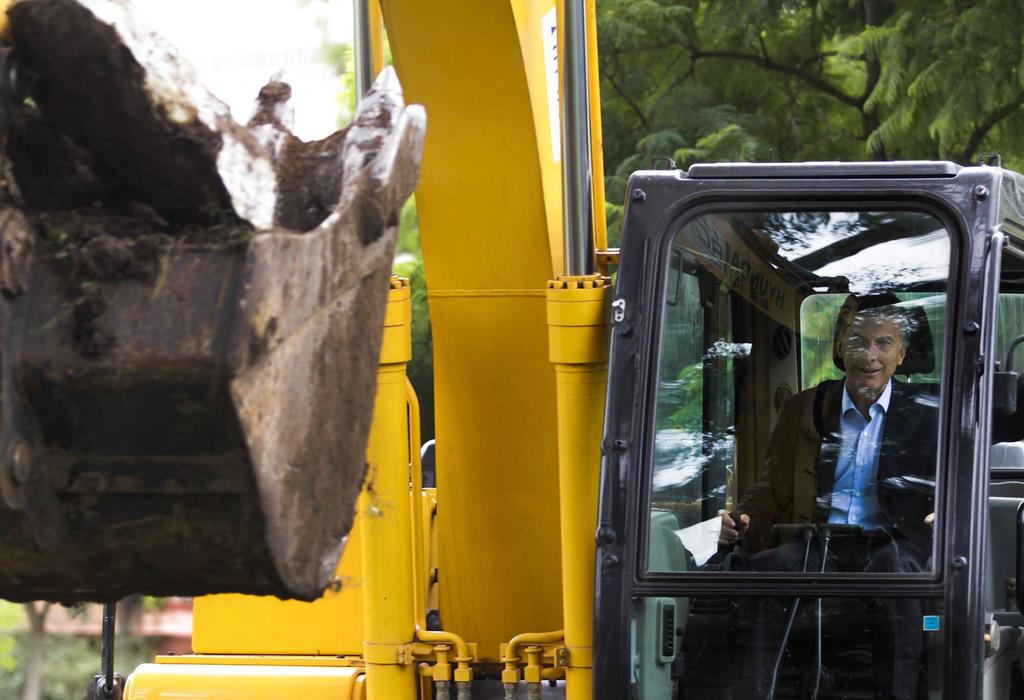Who is present in the image? There is a man in the image. What is the man doing in the image? The man is sitting inside a vehicle. Where is the vehicle located in the image? The vehicle is on the right side of the image. What can be seen in the background of the image? There are trees in the background of the image. What type of stove is visible in the image? There is no stove present in the image. What does the man believe about the trees in the background? The image does not provide any information about the man's beliefs or thoughts, so we cannot answer this question. 